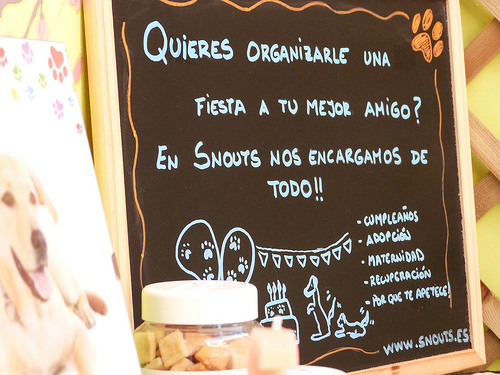<image>
Is the board in front of the dog board? No. The board is not in front of the dog board. The spatial positioning shows a different relationship between these objects. 